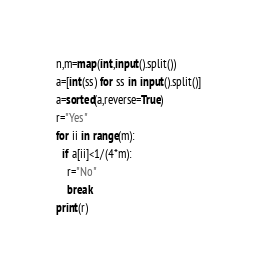<code> <loc_0><loc_0><loc_500><loc_500><_Python_>n,m=map(int,input().split())
a=[int(ss) for ss in input().split()]
a=sorted(a,reverse=True)
r="Yes"
for ii in range(m):
  if a[ii]<1/(4*m):
    r="No"
    break
print(r)</code> 